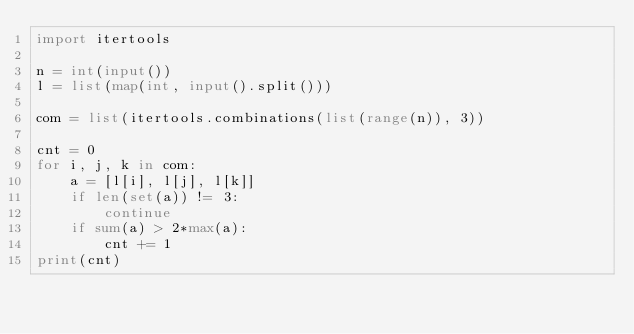<code> <loc_0><loc_0><loc_500><loc_500><_Python_>import itertools

n = int(input())
l = list(map(int, input().split()))

com = list(itertools.combinations(list(range(n)), 3))

cnt = 0
for i, j, k in com:
    a = [l[i], l[j], l[k]]
    if len(set(a)) != 3:
        continue
    if sum(a) > 2*max(a):
        cnt += 1
print(cnt)
</code> 